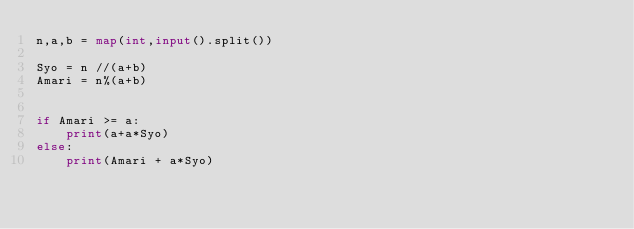Convert code to text. <code><loc_0><loc_0><loc_500><loc_500><_Python_>n,a,b = map(int,input().split())

Syo = n //(a+b)
Amari = n%(a+b)


if Amari >= a:
    print(a+a*Syo)
else:
    print(Amari + a*Syo)
</code> 